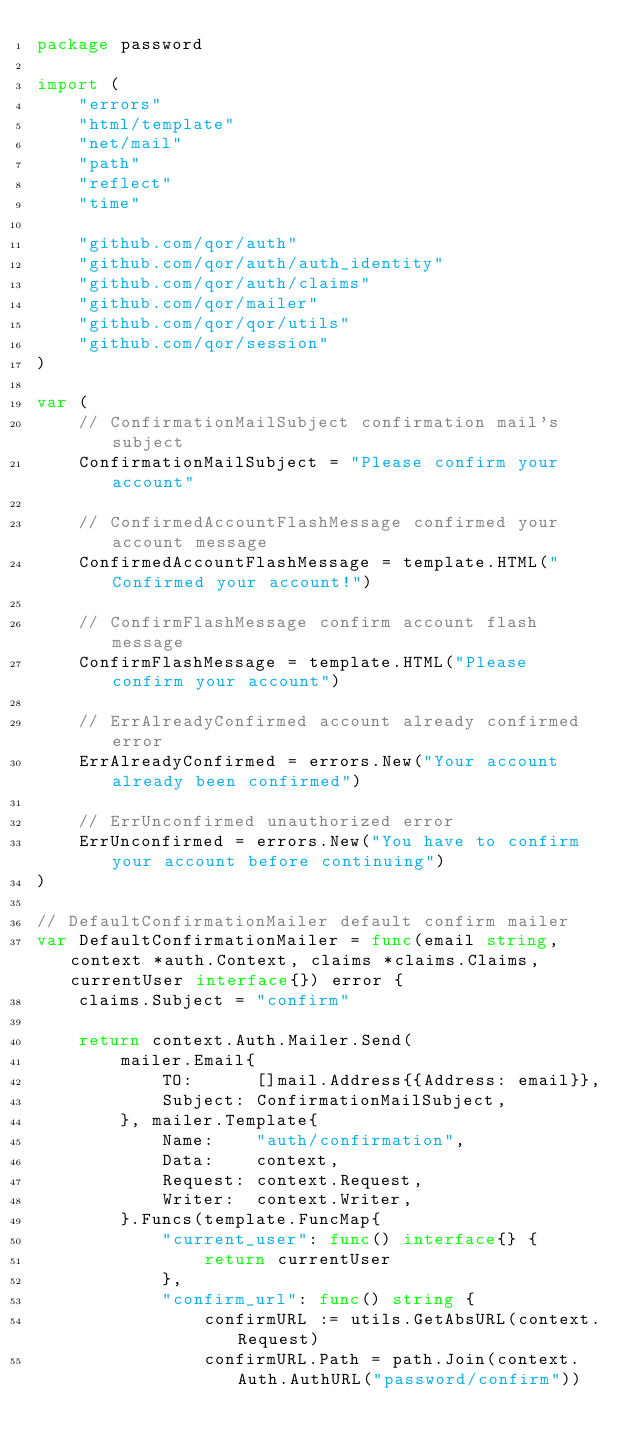Convert code to text. <code><loc_0><loc_0><loc_500><loc_500><_Go_>package password

import (
	"errors"
	"html/template"
	"net/mail"
	"path"
	"reflect"
	"time"

	"github.com/qor/auth"
	"github.com/qor/auth/auth_identity"
	"github.com/qor/auth/claims"
	"github.com/qor/mailer"
	"github.com/qor/qor/utils"
	"github.com/qor/session"
)

var (
	// ConfirmationMailSubject confirmation mail's subject
	ConfirmationMailSubject = "Please confirm your account"

	// ConfirmedAccountFlashMessage confirmed your account message
	ConfirmedAccountFlashMessage = template.HTML("Confirmed your account!")

	// ConfirmFlashMessage confirm account flash message
	ConfirmFlashMessage = template.HTML("Please confirm your account")

	// ErrAlreadyConfirmed account already confirmed error
	ErrAlreadyConfirmed = errors.New("Your account already been confirmed")

	// ErrUnconfirmed unauthorized error
	ErrUnconfirmed = errors.New("You have to confirm your account before continuing")
)

// DefaultConfirmationMailer default confirm mailer
var DefaultConfirmationMailer = func(email string, context *auth.Context, claims *claims.Claims, currentUser interface{}) error {
	claims.Subject = "confirm"

	return context.Auth.Mailer.Send(
		mailer.Email{
			TO:      []mail.Address{{Address: email}},
			Subject: ConfirmationMailSubject,
		}, mailer.Template{
			Name:    "auth/confirmation",
			Data:    context,
			Request: context.Request,
			Writer:  context.Writer,
		}.Funcs(template.FuncMap{
			"current_user": func() interface{} {
				return currentUser
			},
			"confirm_url": func() string {
				confirmURL := utils.GetAbsURL(context.Request)
				confirmURL.Path = path.Join(context.Auth.AuthURL("password/confirm"))</code> 